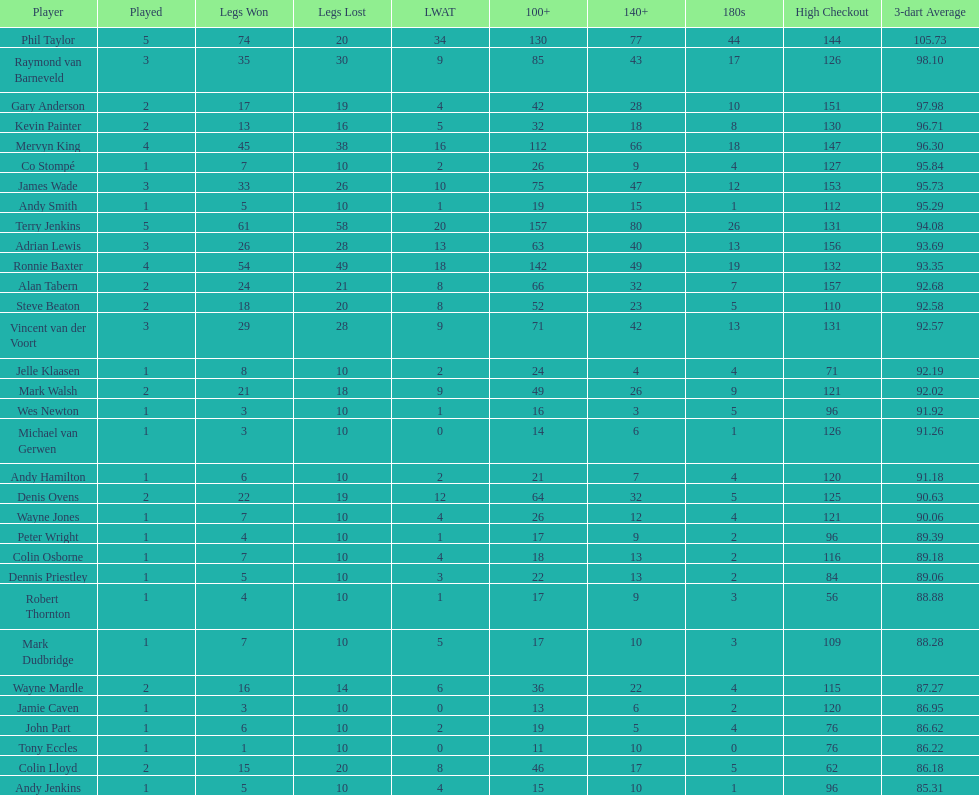Which player has a high checkout of 116? Colin Osborne. 